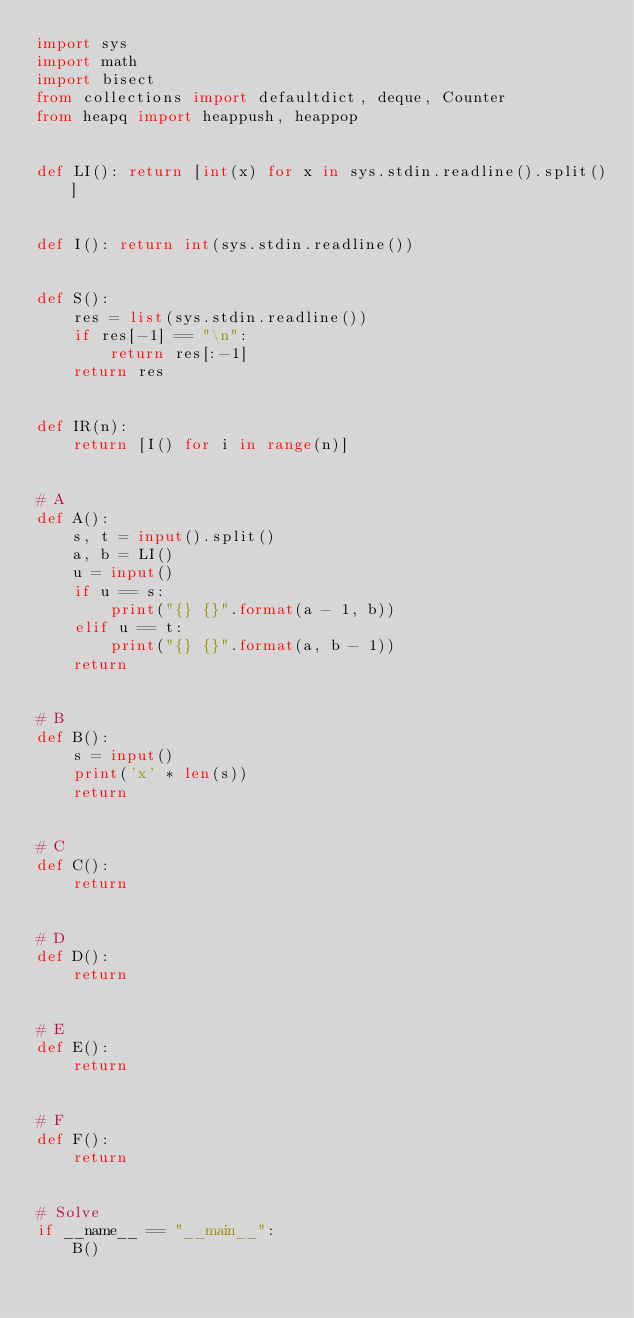<code> <loc_0><loc_0><loc_500><loc_500><_Python_>import sys
import math
import bisect
from collections import defaultdict, deque, Counter
from heapq import heappush, heappop


def LI(): return [int(x) for x in sys.stdin.readline().split()]


def I(): return int(sys.stdin.readline())


def S():
    res = list(sys.stdin.readline())
    if res[-1] == "\n":
        return res[:-1]
    return res


def IR(n):
    return [I() for i in range(n)]


# A
def A():
    s, t = input().split()
    a, b = LI()
    u = input()
    if u == s:
        print("{} {}".format(a - 1, b))
    elif u == t:
        print("{} {}".format(a, b - 1))
    return


# B
def B():
    s = input()
    print('x' * len(s))
    return


# C
def C():
    return


# D
def D():
    return


# E
def E():
    return


# F
def F():
    return


# Solve
if __name__ == "__main__":
    B()
</code> 